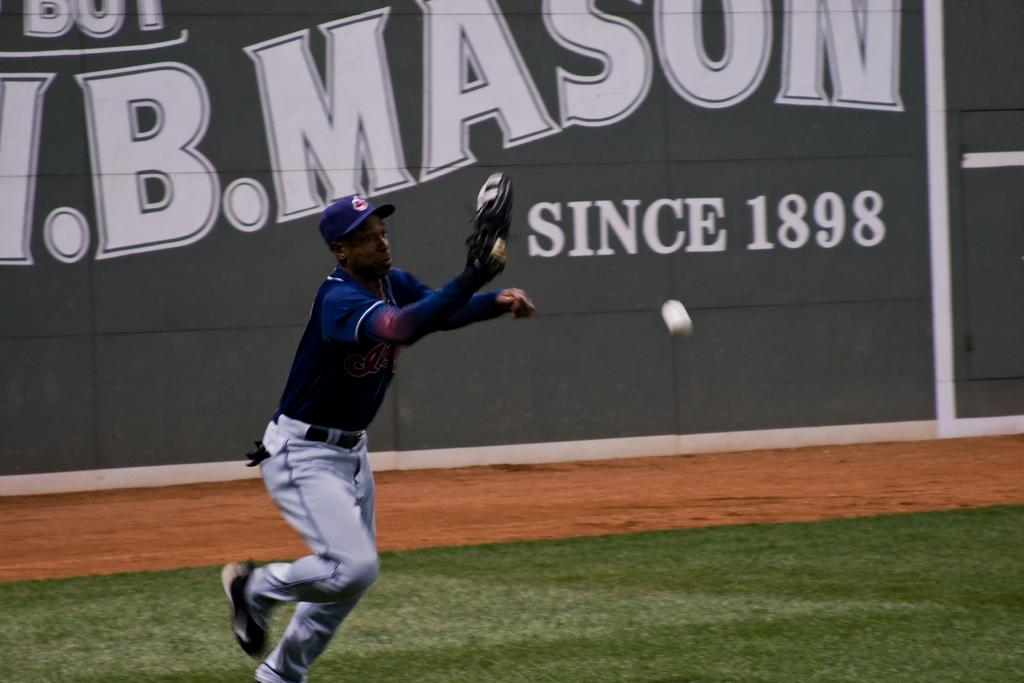<image>
Share a concise interpretation of the image provided. Baseball player catching a ball in front of the wall with Since 1898 in white letters. 